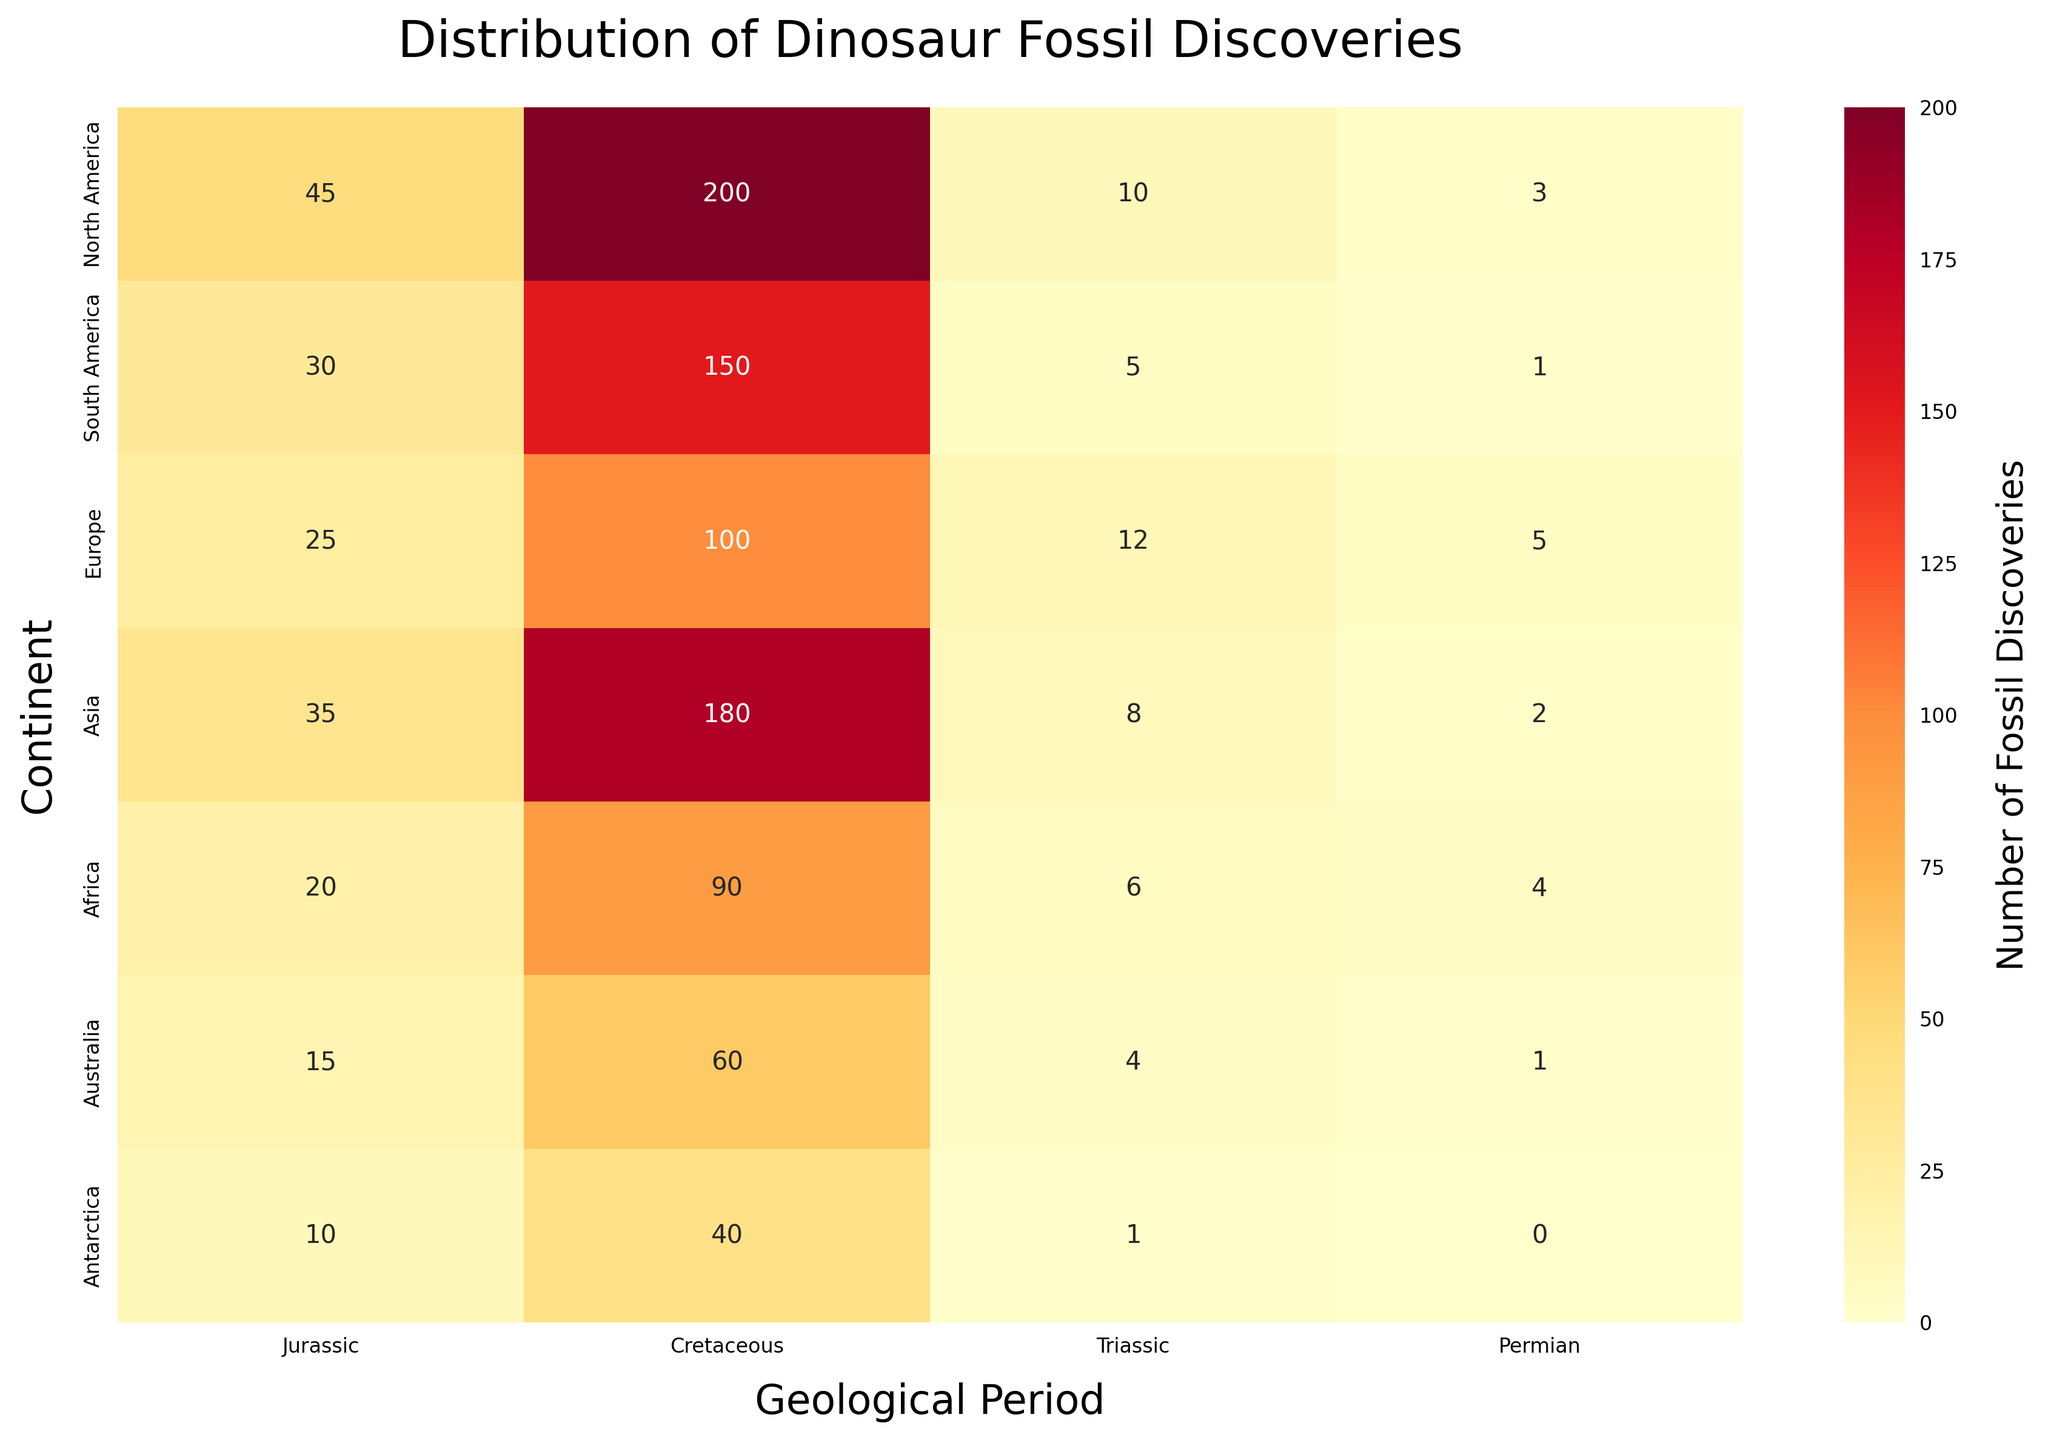What's the title of the heatmap? The title is prominently displayed at the top of the heatmap and reads "Distribution of Dinosaur Fossil Discoveries".
Answer: Distribution of Dinosaur Fossil Discoveries Which continent has the highest number of dinosaur fossil discoveries during the Cretaceous period? To find this, look at the Cretaceous column and identify the highest number. North America has the maximum count of 200.
Answer: North America What is the sum of dinosaur fossil discoveries in Europe during the Jurassic and Triassic periods? Add the values for Europe in the Jurassic (25) and Triassic (12) periods. The sum is 25 + 12 = 37.
Answer: 37 How many more dinosaur fossils were discovered in Asia during the Cretaceous period compared to the Triassic period? Subtract the number of fossils in the Triassic (8) from the number in the Cretaceous (180). The difference is 180 - 8 = 172.
Answer: 172 Which continent has the least number of fossil discoveries during the Permian period? Examine the Permian column and find the lowest number. Antarctica has 0 fossil discoveries during this period.
Answer: Antarctica What's the average number of dinosaur fossil discoveries in Australia across all periods? Sum the values for Australia (15 + 60 + 4 + 1), then divide by the number of periods (4). The average is (15 + 60 + 4 + 1) / 4 = 20.
Answer: 20 Which period had the highest number of dinosaur fossil discoveries in total across all continents? Sum the discoveries for each period across all continents and compare. The Cretaceous has the highest sum: 200 + 150 + 100 + 180 + 90 + 60 + 40 = 820.
Answer: Cretaceous How does the number of dinosaur fossils discovered in North America during the Jurassic period compare to those discovered in Europe during the same period? Compare the values for North America (45) and Europe (25) during the Jurassic period. North America has more discoveries.
Answer: North America Is there any period where the number of fossil discoveries is the same for different continents? If so, which continents and period? Look for identical values in any period column. For the Triassic period, North America and Asia both have 10 fossil discoveries.
Answer: North America and Asia in Triassic What is the total number of dinosaur fossil discoveries in Antarctica across all periods? Sum the values for Antarctica (10 + 40 + 1 + 0). The total is 10 + 40 + 1 + 0 = 51.
Answer: 51 